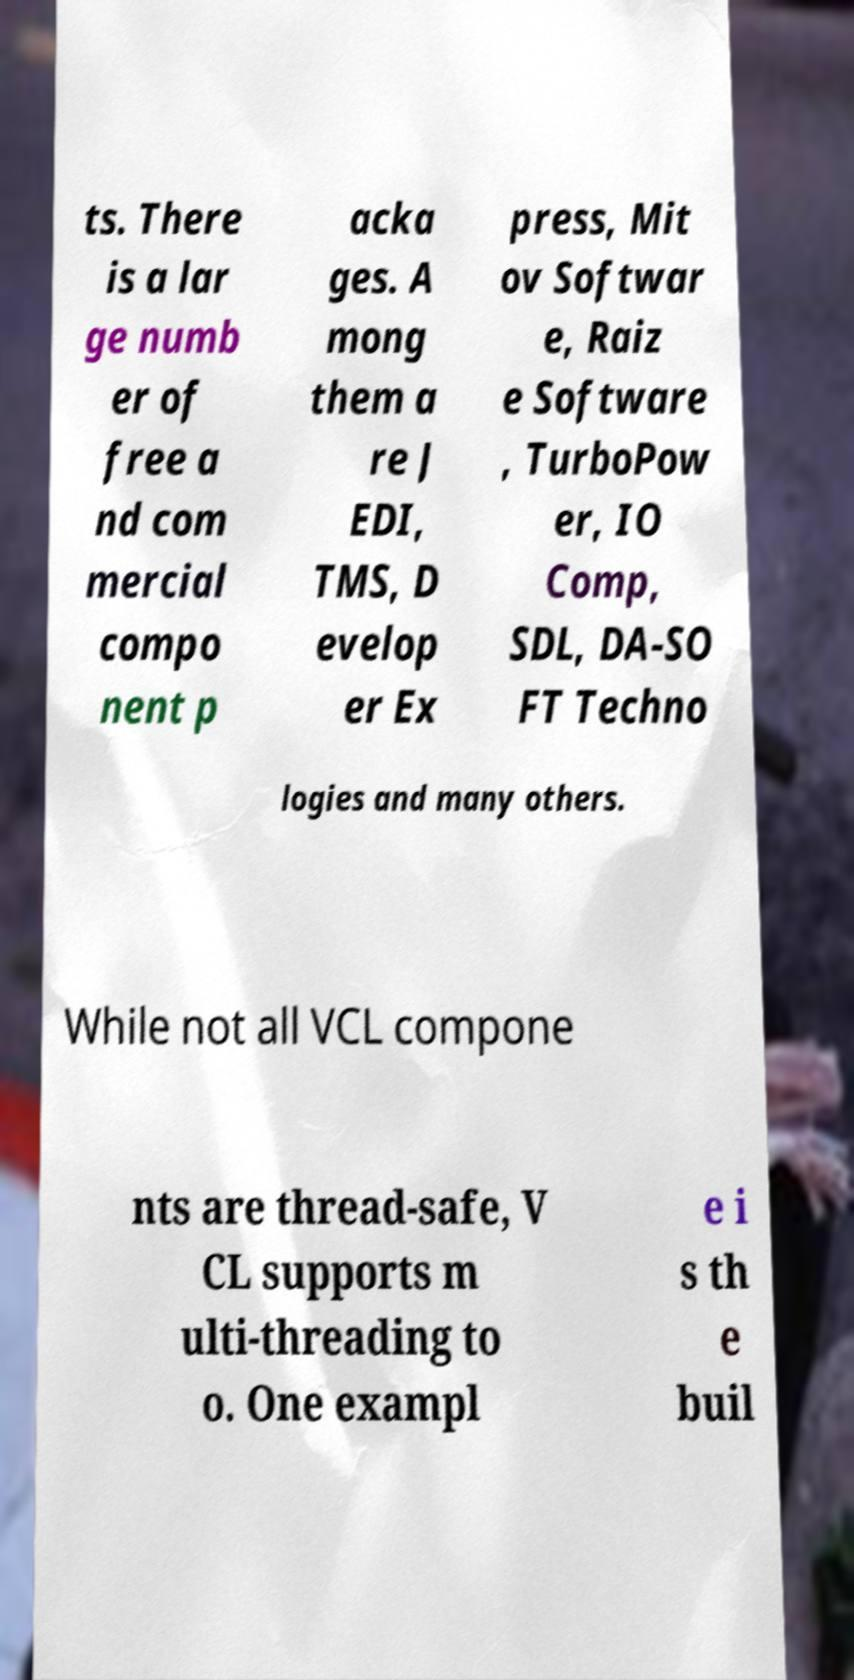What messages or text are displayed in this image? I need them in a readable, typed format. ts. There is a lar ge numb er of free a nd com mercial compo nent p acka ges. A mong them a re J EDI, TMS, D evelop er Ex press, Mit ov Softwar e, Raiz e Software , TurboPow er, IO Comp, SDL, DA-SO FT Techno logies and many others. While not all VCL compone nts are thread-safe, V CL supports m ulti-threading to o. One exampl e i s th e buil 